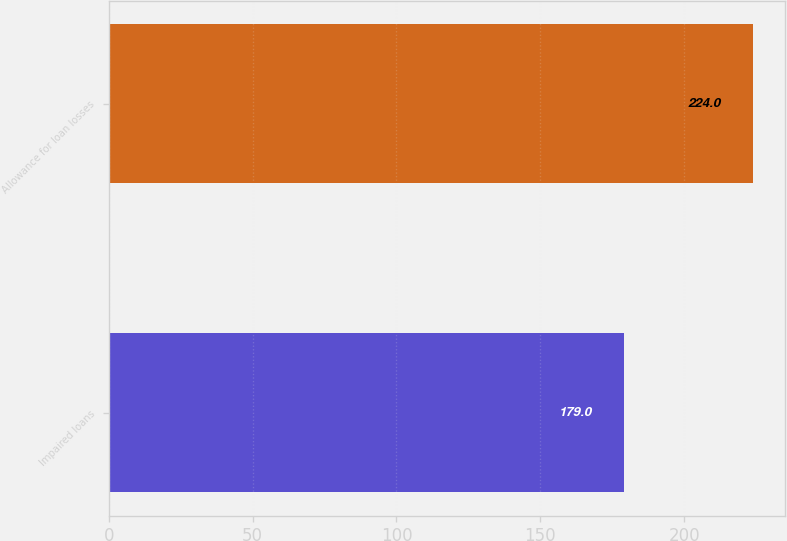<chart> <loc_0><loc_0><loc_500><loc_500><bar_chart><fcel>Impaired loans<fcel>Allowance for loan losses<nl><fcel>179<fcel>224<nl></chart> 